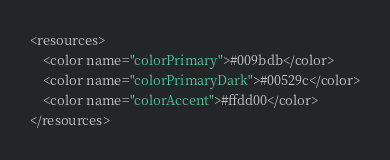<code> <loc_0><loc_0><loc_500><loc_500><_XML_><resources>
    <color name="colorPrimary">#009bdb</color>
    <color name="colorPrimaryDark">#00529c</color>
    <color name="colorAccent">#ffdd00</color>
</resources>
</code> 